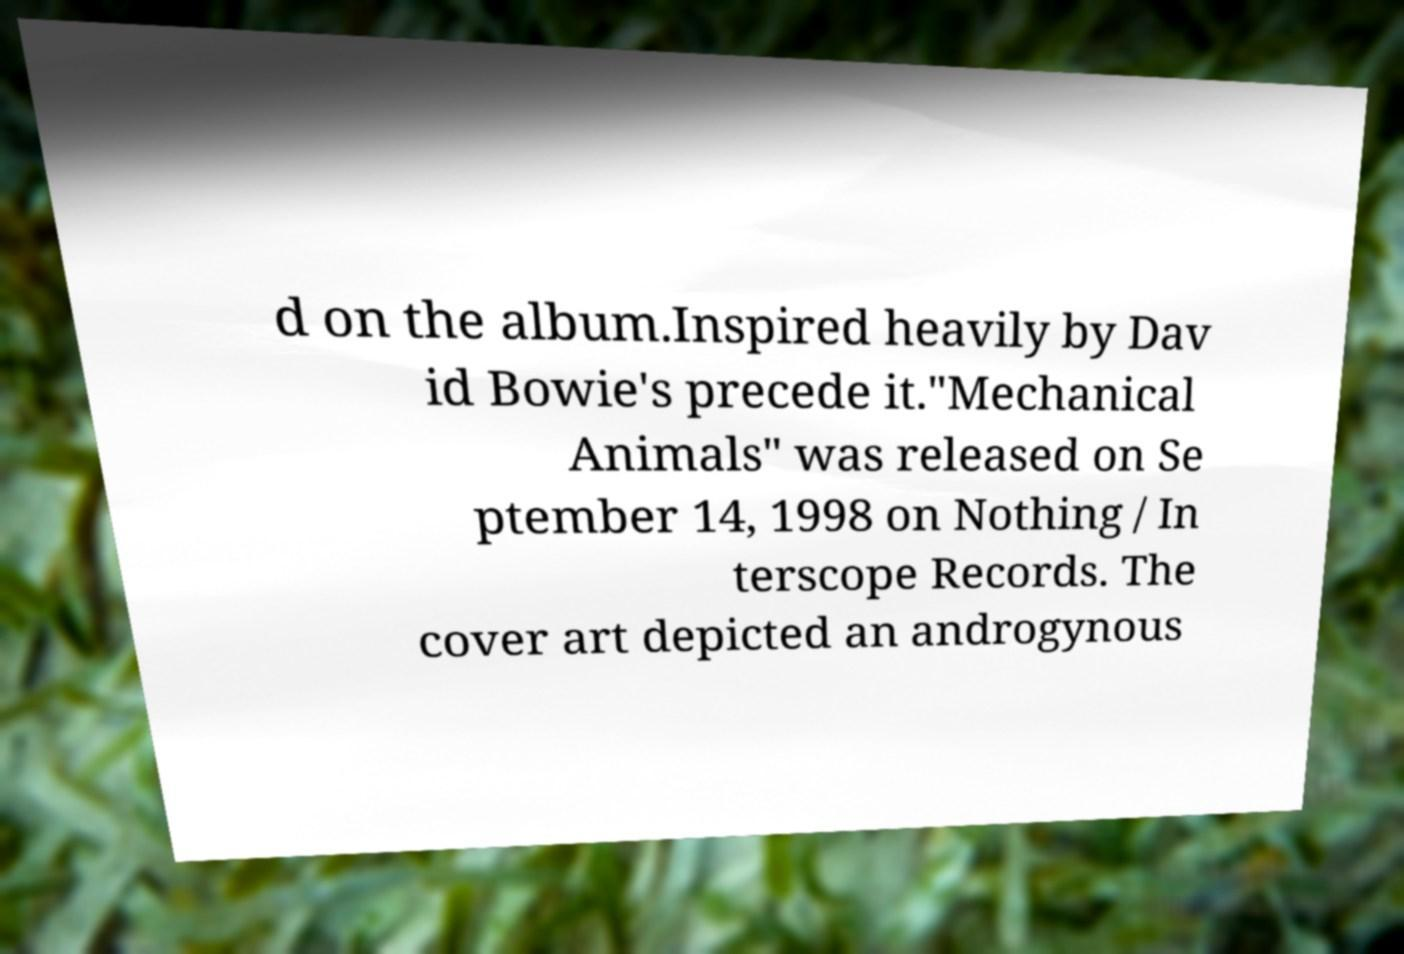What messages or text are displayed in this image? I need them in a readable, typed format. d on the album.Inspired heavily by Dav id Bowie's precede it."Mechanical Animals" was released on Se ptember 14, 1998 on Nothing / In terscope Records. The cover art depicted an androgynous 